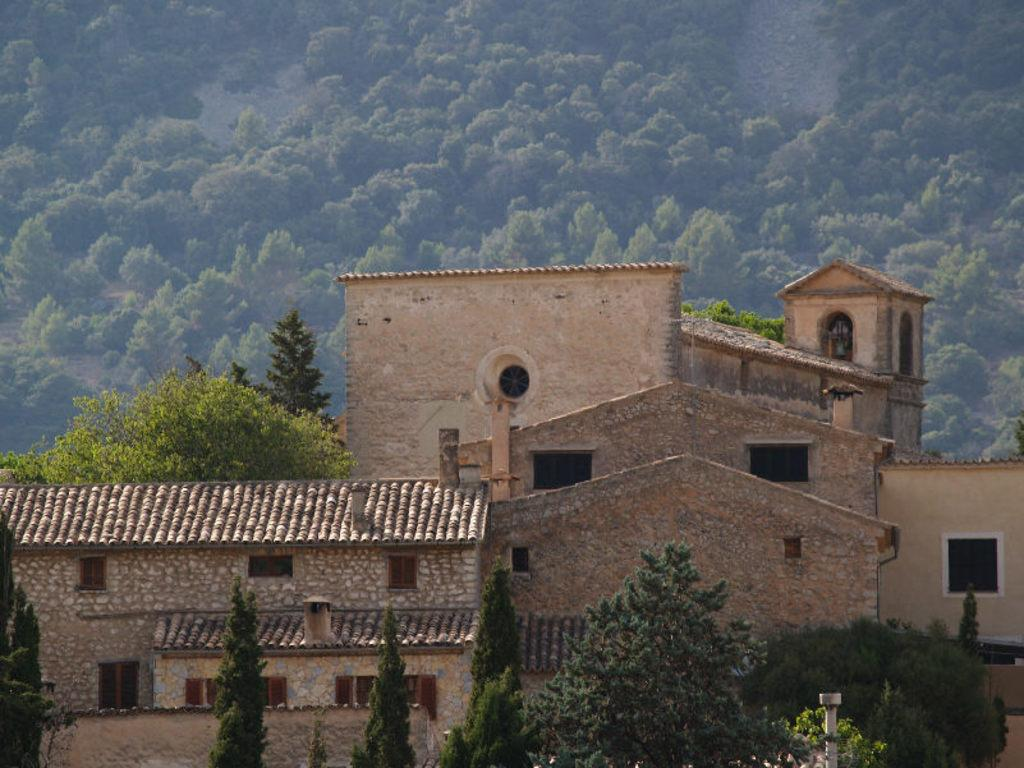What type of vegetation is visible in the front of the image? There are trees in the front of the image. What type of structures are located in the center of the image? There are buildings in the center of the image. What type of vegetation is visible in the background of the image? There are trees in the background of the image. Can you tell me how many lawyers are present in the image? There is no mention of lawyers or any legal professionals in the image. Is there a judge visible in the image? There is no mention of a judge or any judicial figures in the image. 